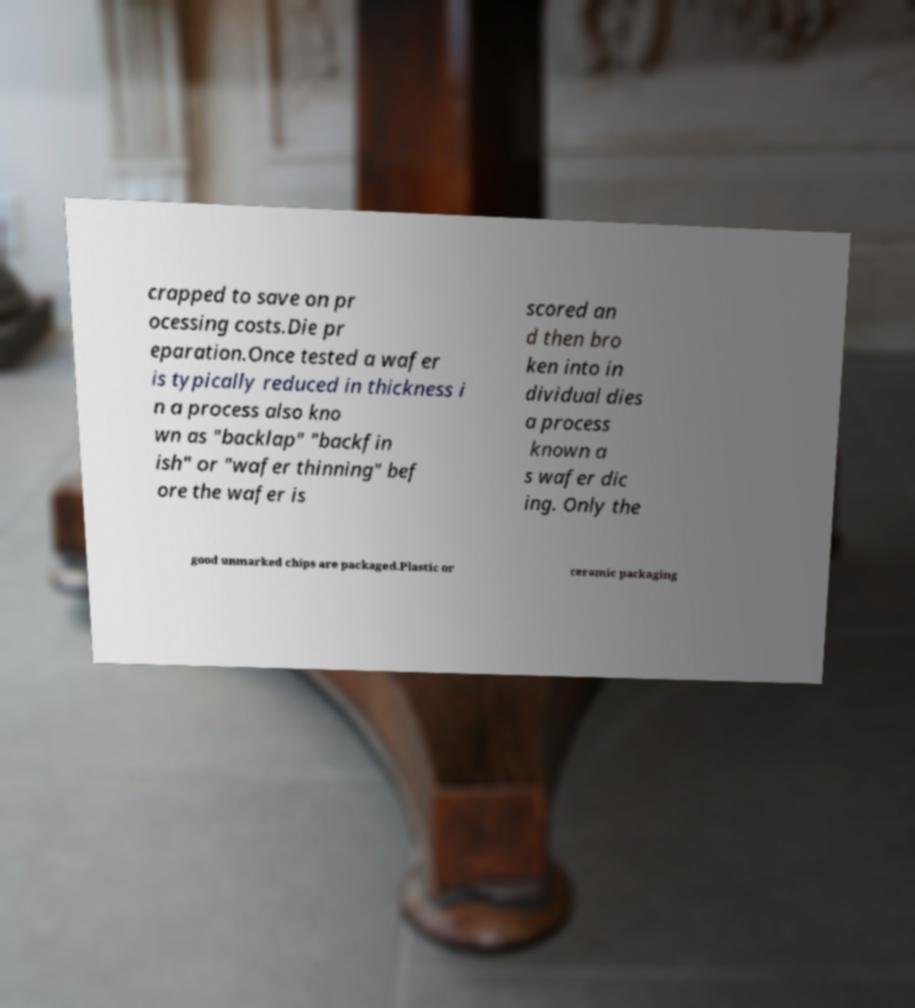Can you read and provide the text displayed in the image?This photo seems to have some interesting text. Can you extract and type it out for me? crapped to save on pr ocessing costs.Die pr eparation.Once tested a wafer is typically reduced in thickness i n a process also kno wn as "backlap" "backfin ish" or "wafer thinning" bef ore the wafer is scored an d then bro ken into in dividual dies a process known a s wafer dic ing. Only the good unmarked chips are packaged.Plastic or ceramic packaging 